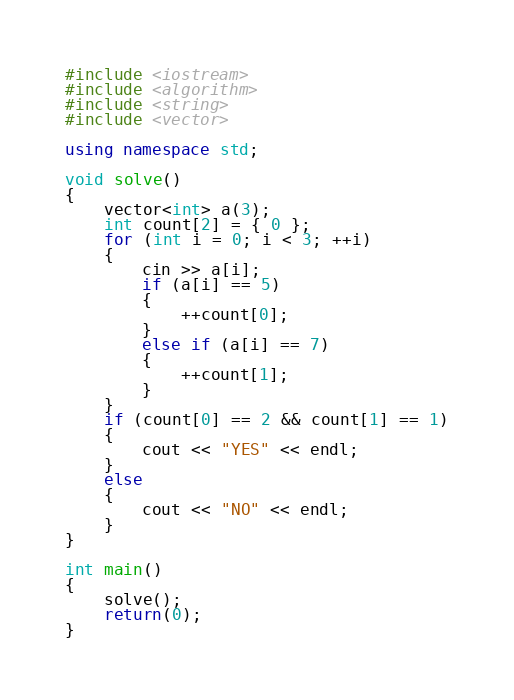Convert code to text. <code><loc_0><loc_0><loc_500><loc_500><_C++_>#include <iostream>
#include <algorithm>
#include <string>
#include <vector>

using namespace std;

void solve()
{
	vector<int> a(3);
	int count[2] = { 0 };
	for (int i = 0; i < 3; ++i)
	{
		cin >> a[i];
		if (a[i] == 5)
		{
			++count[0];
		}
		else if (a[i] == 7)
		{
			++count[1];
		}
	}
	if (count[0] == 2 && count[1] == 1)
	{
		cout << "YES" << endl;
	}
	else
	{
		cout << "NO" << endl;
	}
}

int main()
{
	solve();
	return(0);
}</code> 